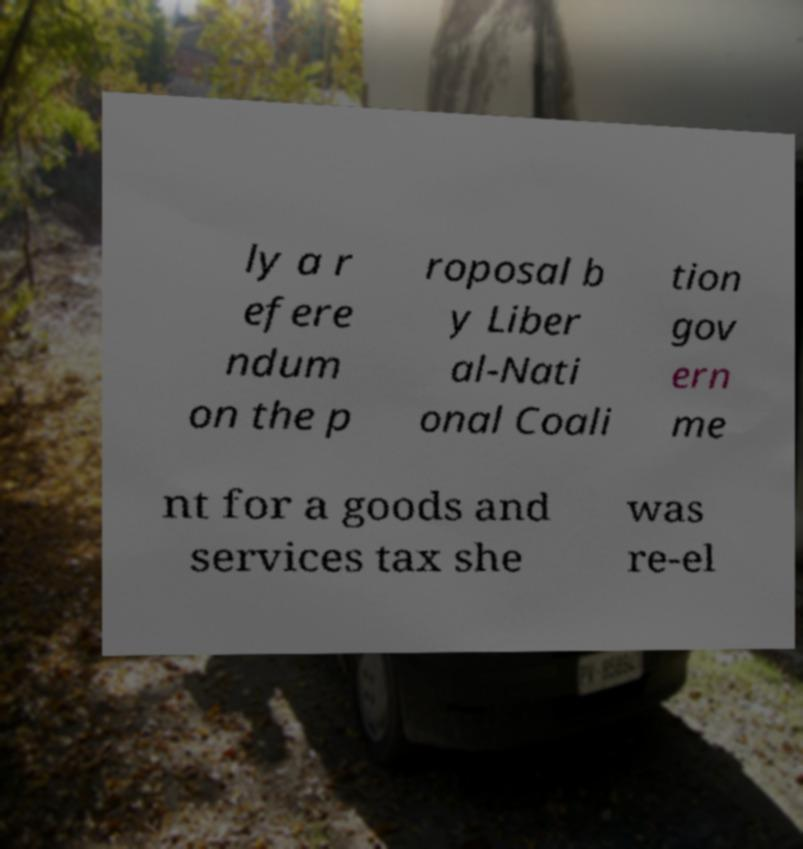I need the written content from this picture converted into text. Can you do that? ly a r efere ndum on the p roposal b y Liber al-Nati onal Coali tion gov ern me nt for a goods and services tax she was re-el 